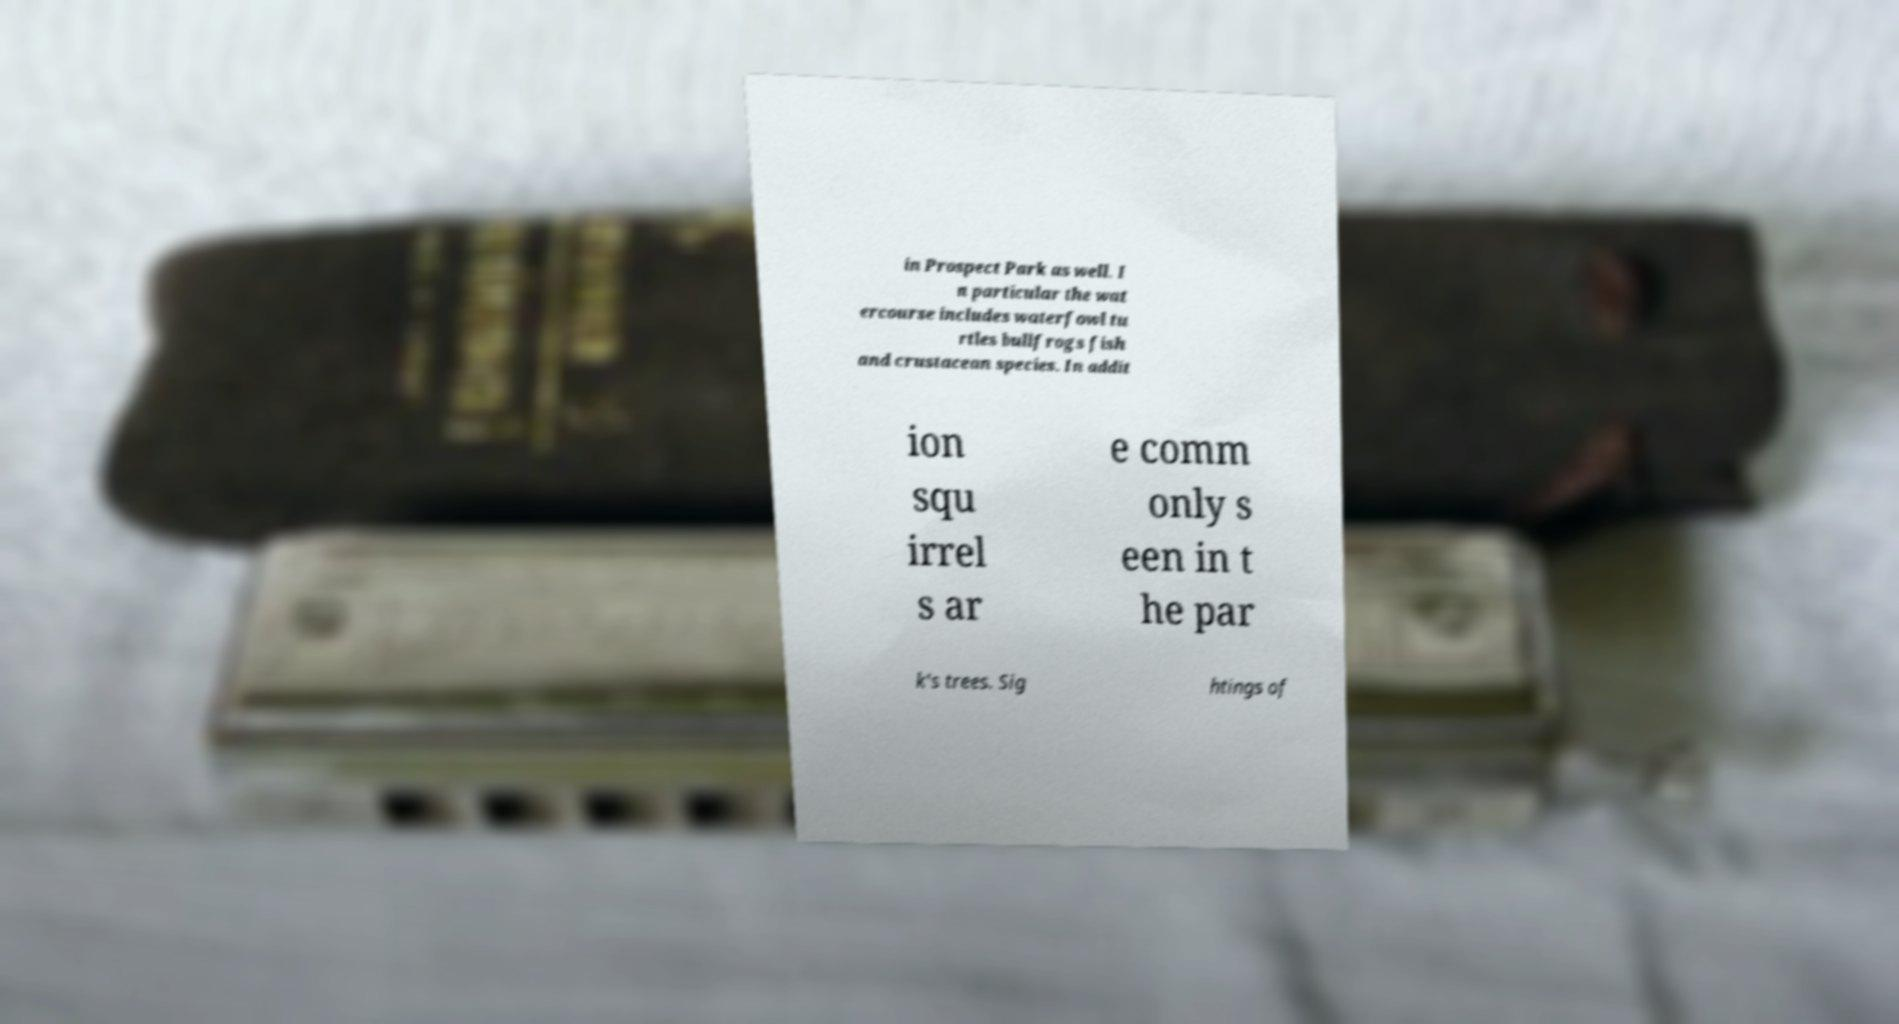What messages or text are displayed in this image? I need them in a readable, typed format. in Prospect Park as well. I n particular the wat ercourse includes waterfowl tu rtles bullfrogs fish and crustacean species. In addit ion squ irrel s ar e comm only s een in t he par k's trees. Sig htings of 